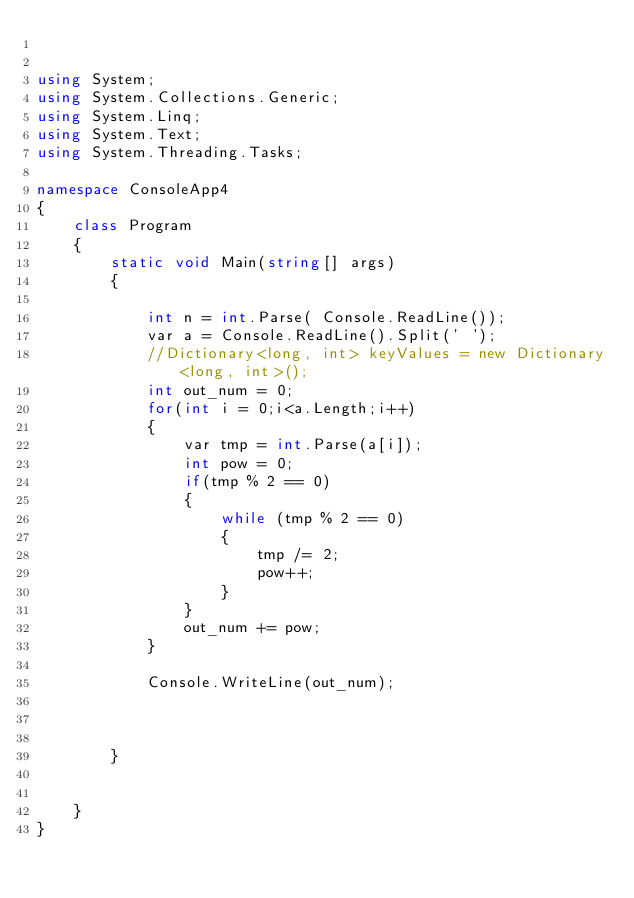Convert code to text. <code><loc_0><loc_0><loc_500><loc_500><_C#_>

using System;
using System.Collections.Generic;
using System.Linq;
using System.Text;
using System.Threading.Tasks;

namespace ConsoleApp4
{
    class Program
    {
        static void Main(string[] args)
        {

            int n = int.Parse( Console.ReadLine());
            var a = Console.ReadLine().Split(' ');
            //Dictionary<long, int> keyValues = new Dictionary<long, int>();
            int out_num = 0;
            for(int i = 0;i<a.Length;i++)
            {
                var tmp = int.Parse(a[i]);
                int pow = 0;
                if(tmp % 2 == 0)
                {
                    while (tmp % 2 == 0)
                    {
                        tmp /= 2;
                        pow++;
                    }
                }
                out_num += pow;
            }

            Console.WriteLine(out_num);



        }


    }
}

</code> 